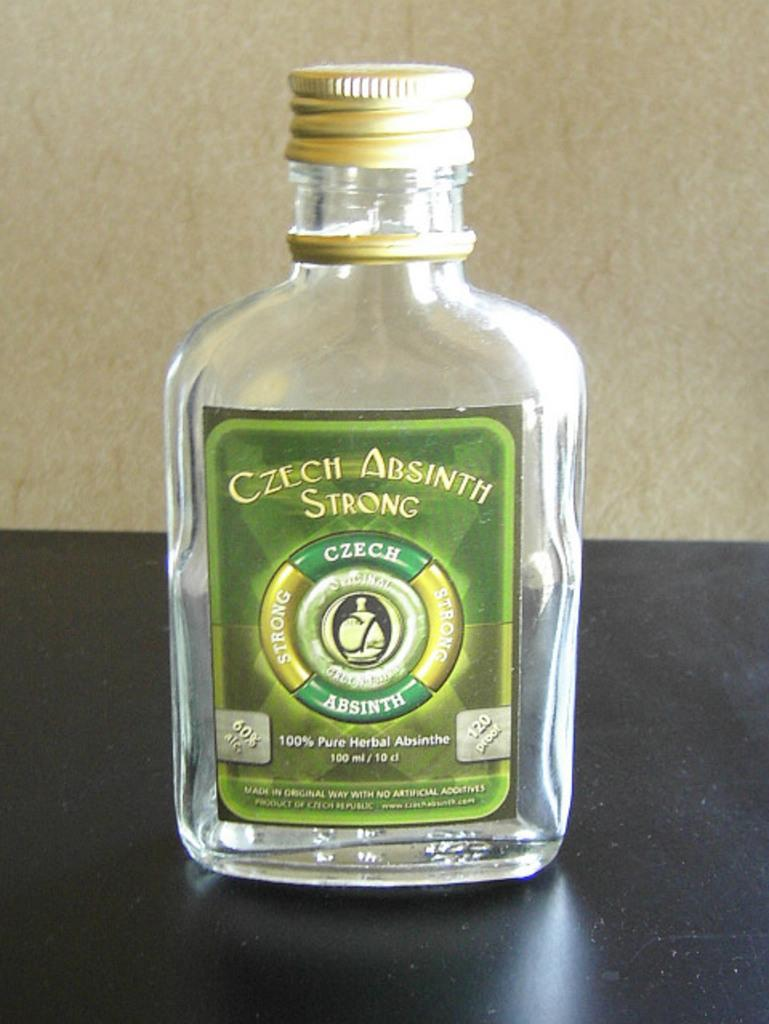Provide a one-sentence caption for the provided image. Almost empty bottle of Czech Absinth strong that is herbal. 